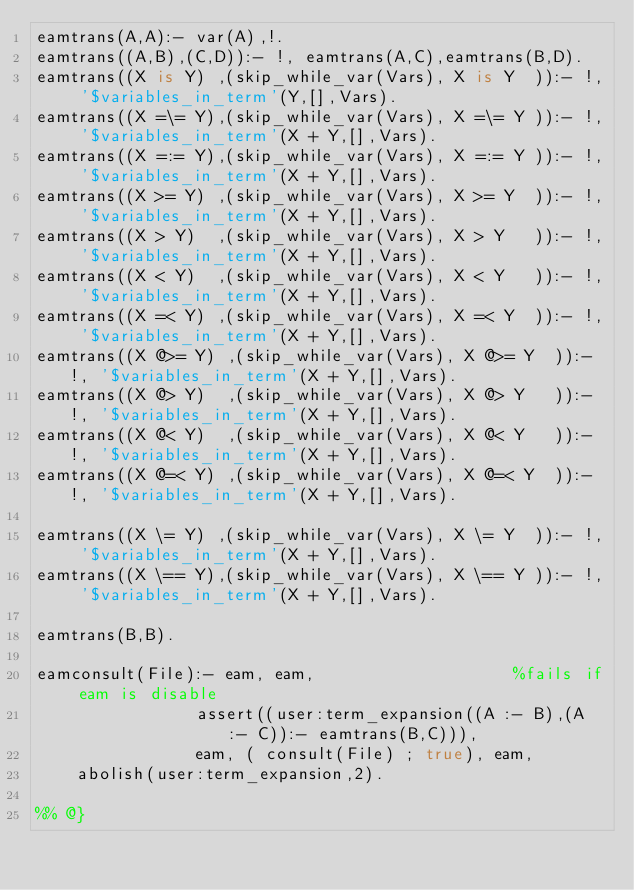<code> <loc_0><loc_0><loc_500><loc_500><_Prolog_>eamtrans(A,A):- var(A),!.
eamtrans((A,B),(C,D)):- !, eamtrans(A,C),eamtrans(B,D).
eamtrans((X is Y) ,(skip_while_var(Vars), X is Y  )):- !, '$variables_in_term'(Y,[],Vars).
eamtrans((X =\= Y),(skip_while_var(Vars), X =\= Y )):- !, '$variables_in_term'(X + Y,[],Vars).
eamtrans((X =:= Y),(skip_while_var(Vars), X =:= Y )):- !, '$variables_in_term'(X + Y,[],Vars).
eamtrans((X >= Y) ,(skip_while_var(Vars), X >= Y  )):- !, '$variables_in_term'(X + Y,[],Vars).
eamtrans((X > Y)  ,(skip_while_var(Vars), X > Y   )):- !, '$variables_in_term'(X + Y,[],Vars).
eamtrans((X < Y)  ,(skip_while_var(Vars), X < Y   )):- !, '$variables_in_term'(X + Y,[],Vars).
eamtrans((X =< Y) ,(skip_while_var(Vars), X =< Y  )):- !, '$variables_in_term'(X + Y,[],Vars).
eamtrans((X @>= Y) ,(skip_while_var(Vars), X @>= Y  )):- !, '$variables_in_term'(X + Y,[],Vars).
eamtrans((X @> Y)  ,(skip_while_var(Vars), X @> Y   )):- !, '$variables_in_term'(X + Y,[],Vars).
eamtrans((X @< Y)  ,(skip_while_var(Vars), X @< Y   )):- !, '$variables_in_term'(X + Y,[],Vars).
eamtrans((X @=< Y) ,(skip_while_var(Vars), X @=< Y  )):- !, '$variables_in_term'(X + Y,[],Vars).

eamtrans((X \= Y) ,(skip_while_var(Vars), X \= Y  )):- !, '$variables_in_term'(X + Y,[],Vars).
eamtrans((X \== Y),(skip_while_var(Vars), X \== Y )):- !, '$variables_in_term'(X + Y,[],Vars).

eamtrans(B,B).

eamconsult(File):- eam, eam,                    %fails if eam is disable
                assert((user:term_expansion((A :- B),(A :- C)):- eamtrans(B,C))),
                eam, ( consult(File) ; true), eam,
		abolish(user:term_expansion,2).

%% @}
</code> 